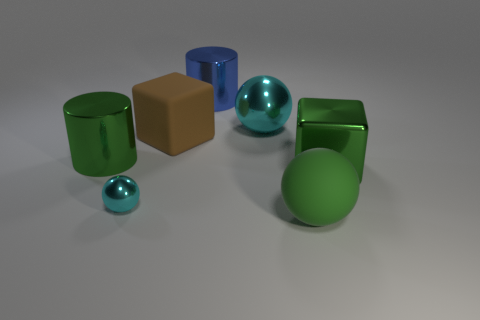Are there any objects that stand out due to their different shape? Yes, the brown cube stands out as it is the only object in the image with a cuboid shape, contrasting with the cylindrical and spherical shapes of the other objects. 